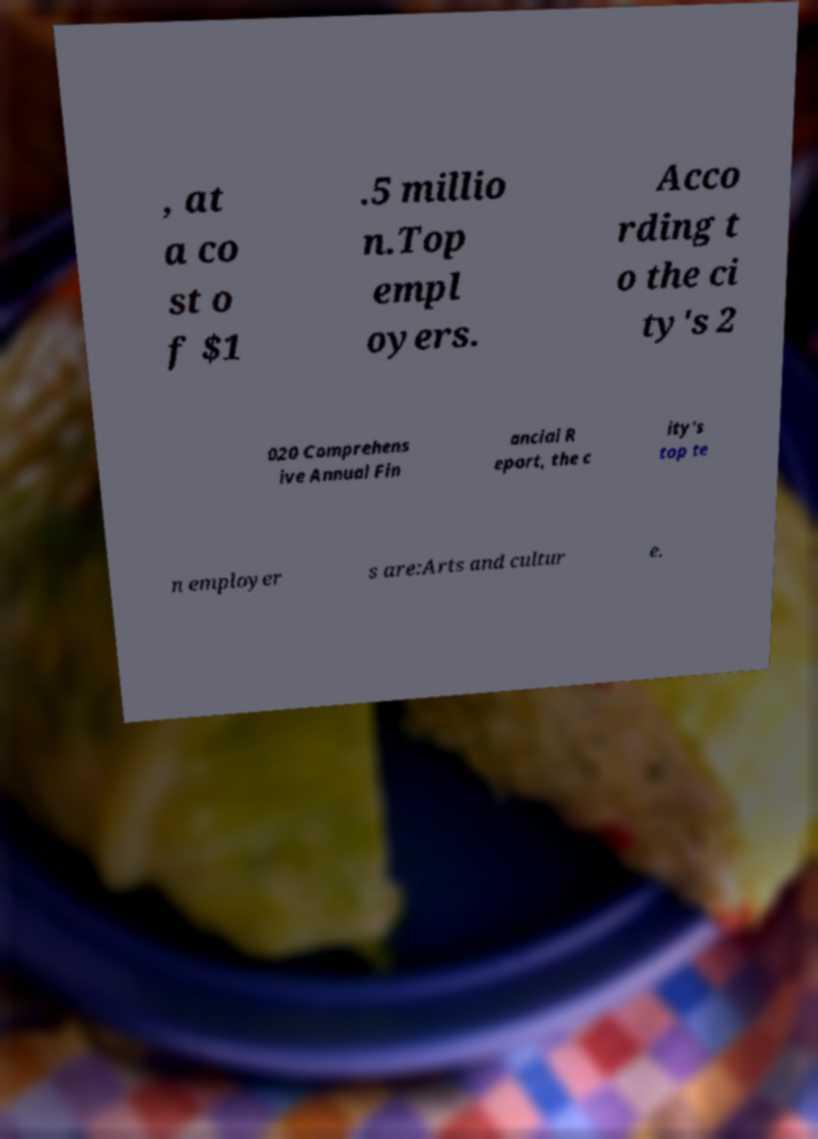What messages or text are displayed in this image? I need them in a readable, typed format. , at a co st o f $1 .5 millio n.Top empl oyers. Acco rding t o the ci ty's 2 020 Comprehens ive Annual Fin ancial R eport, the c ity's top te n employer s are:Arts and cultur e. 